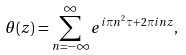<formula> <loc_0><loc_0><loc_500><loc_500>\theta ( z ) = \sum _ { n = - \infty } ^ { \infty } e ^ { i \pi n ^ { 2 } \tau + 2 \pi i n z } ,</formula> 